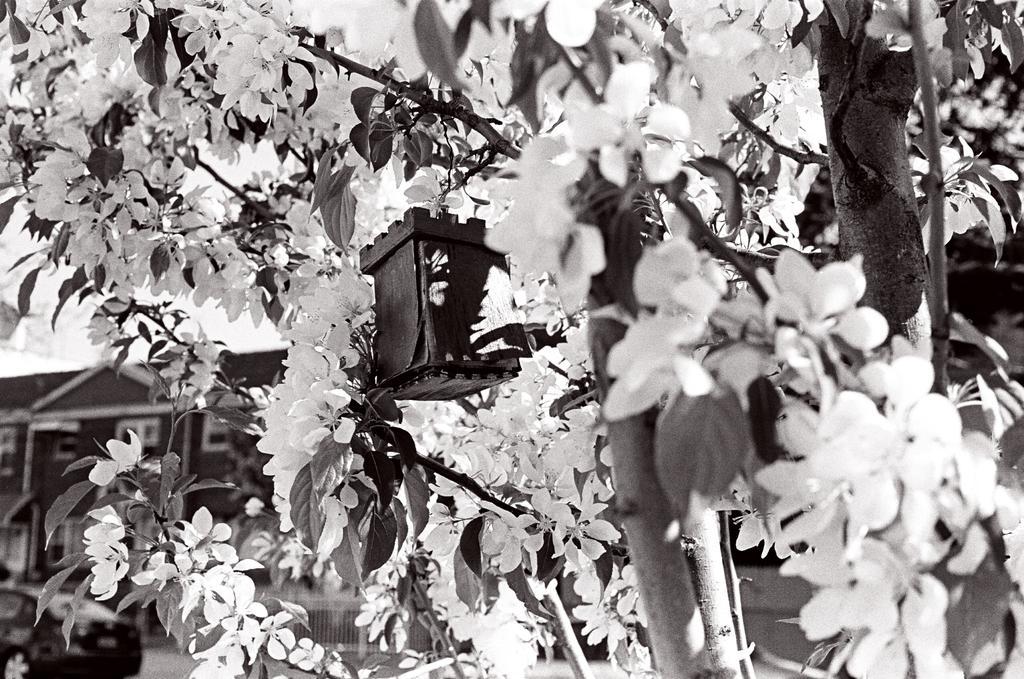How would you summarize this image in a sentence or two? It is a black and white picture. In the front of the image there is a trees, branches and objects. In the background of the image it is blurry. There is a building, vehicle and railing. 